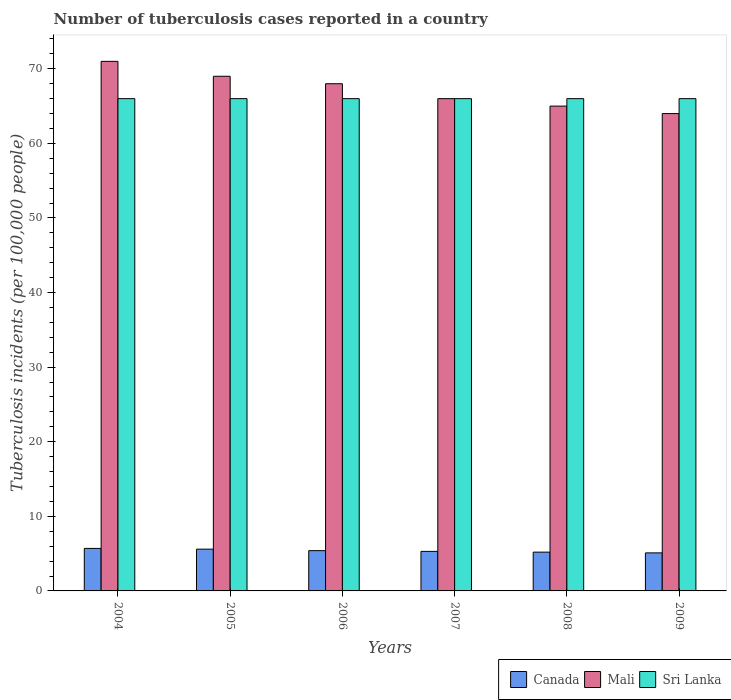How many groups of bars are there?
Make the answer very short. 6. How many bars are there on the 3rd tick from the right?
Offer a terse response. 3. What is the label of the 2nd group of bars from the left?
Offer a terse response. 2005. Across all years, what is the maximum number of tuberculosis cases reported in in Mali?
Ensure brevity in your answer.  71. What is the total number of tuberculosis cases reported in in Mali in the graph?
Your answer should be very brief. 403. What is the difference between the number of tuberculosis cases reported in in Canada in 2006 and that in 2008?
Offer a very short reply. 0.2. What is the difference between the number of tuberculosis cases reported in in Sri Lanka in 2006 and the number of tuberculosis cases reported in in Canada in 2004?
Give a very brief answer. 60.3. What is the average number of tuberculosis cases reported in in Canada per year?
Your response must be concise. 5.38. In the year 2004, what is the difference between the number of tuberculosis cases reported in in Sri Lanka and number of tuberculosis cases reported in in Mali?
Offer a terse response. -5. What is the ratio of the number of tuberculosis cases reported in in Canada in 2006 to that in 2009?
Provide a short and direct response. 1.06. Is the difference between the number of tuberculosis cases reported in in Sri Lanka in 2005 and 2006 greater than the difference between the number of tuberculosis cases reported in in Mali in 2005 and 2006?
Your answer should be compact. No. What is the difference between the highest and the lowest number of tuberculosis cases reported in in Canada?
Your answer should be compact. 0.6. In how many years, is the number of tuberculosis cases reported in in Sri Lanka greater than the average number of tuberculosis cases reported in in Sri Lanka taken over all years?
Your response must be concise. 0. Is the sum of the number of tuberculosis cases reported in in Canada in 2005 and 2009 greater than the maximum number of tuberculosis cases reported in in Sri Lanka across all years?
Your answer should be compact. No. What does the 3rd bar from the left in 2009 represents?
Offer a terse response. Sri Lanka. What does the 2nd bar from the right in 2006 represents?
Offer a terse response. Mali. How many bars are there?
Offer a terse response. 18. Are all the bars in the graph horizontal?
Give a very brief answer. No. What is the difference between two consecutive major ticks on the Y-axis?
Provide a short and direct response. 10. Does the graph contain any zero values?
Your answer should be compact. No. Does the graph contain grids?
Ensure brevity in your answer.  No. How many legend labels are there?
Ensure brevity in your answer.  3. How are the legend labels stacked?
Give a very brief answer. Horizontal. What is the title of the graph?
Offer a very short reply. Number of tuberculosis cases reported in a country. What is the label or title of the X-axis?
Provide a short and direct response. Years. What is the label or title of the Y-axis?
Offer a very short reply. Tuberculosis incidents (per 100,0 people). What is the Tuberculosis incidents (per 100,000 people) in Sri Lanka in 2004?
Make the answer very short. 66. What is the Tuberculosis incidents (per 100,000 people) in Canada in 2006?
Provide a succinct answer. 5.4. What is the Tuberculosis incidents (per 100,000 people) in Mali in 2006?
Keep it short and to the point. 68. What is the Tuberculosis incidents (per 100,000 people) of Sri Lanka in 2006?
Make the answer very short. 66. What is the Tuberculosis incidents (per 100,000 people) in Canada in 2007?
Your answer should be compact. 5.3. What is the Tuberculosis incidents (per 100,000 people) of Mali in 2007?
Your answer should be compact. 66. What is the Tuberculosis incidents (per 100,000 people) in Canada in 2008?
Offer a terse response. 5.2. What is the Tuberculosis incidents (per 100,000 people) in Canada in 2009?
Make the answer very short. 5.1. What is the Tuberculosis incidents (per 100,000 people) of Sri Lanka in 2009?
Offer a terse response. 66. Across all years, what is the minimum Tuberculosis incidents (per 100,000 people) in Sri Lanka?
Give a very brief answer. 66. What is the total Tuberculosis incidents (per 100,000 people) in Canada in the graph?
Make the answer very short. 32.3. What is the total Tuberculosis incidents (per 100,000 people) in Mali in the graph?
Provide a short and direct response. 403. What is the total Tuberculosis incidents (per 100,000 people) of Sri Lanka in the graph?
Give a very brief answer. 396. What is the difference between the Tuberculosis incidents (per 100,000 people) of Canada in 2004 and that in 2005?
Offer a terse response. 0.1. What is the difference between the Tuberculosis incidents (per 100,000 people) of Sri Lanka in 2004 and that in 2006?
Offer a very short reply. 0. What is the difference between the Tuberculosis incidents (per 100,000 people) in Mali in 2004 and that in 2007?
Offer a very short reply. 5. What is the difference between the Tuberculosis incidents (per 100,000 people) in Mali in 2004 and that in 2008?
Provide a succinct answer. 6. What is the difference between the Tuberculosis incidents (per 100,000 people) in Canada in 2004 and that in 2009?
Provide a succinct answer. 0.6. What is the difference between the Tuberculosis incidents (per 100,000 people) of Canada in 2005 and that in 2006?
Offer a very short reply. 0.2. What is the difference between the Tuberculosis incidents (per 100,000 people) in Canada in 2005 and that in 2007?
Provide a succinct answer. 0.3. What is the difference between the Tuberculosis incidents (per 100,000 people) in Mali in 2005 and that in 2007?
Provide a succinct answer. 3. What is the difference between the Tuberculosis incidents (per 100,000 people) of Sri Lanka in 2005 and that in 2009?
Ensure brevity in your answer.  0. What is the difference between the Tuberculosis incidents (per 100,000 people) of Sri Lanka in 2006 and that in 2007?
Make the answer very short. 0. What is the difference between the Tuberculosis incidents (per 100,000 people) in Canada in 2006 and that in 2008?
Your answer should be compact. 0.2. What is the difference between the Tuberculosis incidents (per 100,000 people) in Sri Lanka in 2006 and that in 2008?
Keep it short and to the point. 0. What is the difference between the Tuberculosis incidents (per 100,000 people) in Canada in 2006 and that in 2009?
Provide a short and direct response. 0.3. What is the difference between the Tuberculosis incidents (per 100,000 people) of Canada in 2007 and that in 2008?
Ensure brevity in your answer.  0.1. What is the difference between the Tuberculosis incidents (per 100,000 people) of Mali in 2008 and that in 2009?
Provide a short and direct response. 1. What is the difference between the Tuberculosis incidents (per 100,000 people) in Sri Lanka in 2008 and that in 2009?
Keep it short and to the point. 0. What is the difference between the Tuberculosis incidents (per 100,000 people) in Canada in 2004 and the Tuberculosis incidents (per 100,000 people) in Mali in 2005?
Your response must be concise. -63.3. What is the difference between the Tuberculosis incidents (per 100,000 people) in Canada in 2004 and the Tuberculosis incidents (per 100,000 people) in Sri Lanka in 2005?
Your answer should be compact. -60.3. What is the difference between the Tuberculosis incidents (per 100,000 people) of Canada in 2004 and the Tuberculosis incidents (per 100,000 people) of Mali in 2006?
Your answer should be compact. -62.3. What is the difference between the Tuberculosis incidents (per 100,000 people) in Canada in 2004 and the Tuberculosis incidents (per 100,000 people) in Sri Lanka in 2006?
Offer a terse response. -60.3. What is the difference between the Tuberculosis incidents (per 100,000 people) in Mali in 2004 and the Tuberculosis incidents (per 100,000 people) in Sri Lanka in 2006?
Offer a terse response. 5. What is the difference between the Tuberculosis incidents (per 100,000 people) in Canada in 2004 and the Tuberculosis incidents (per 100,000 people) in Mali in 2007?
Make the answer very short. -60.3. What is the difference between the Tuberculosis incidents (per 100,000 people) in Canada in 2004 and the Tuberculosis incidents (per 100,000 people) in Sri Lanka in 2007?
Keep it short and to the point. -60.3. What is the difference between the Tuberculosis incidents (per 100,000 people) of Mali in 2004 and the Tuberculosis incidents (per 100,000 people) of Sri Lanka in 2007?
Offer a terse response. 5. What is the difference between the Tuberculosis incidents (per 100,000 people) in Canada in 2004 and the Tuberculosis incidents (per 100,000 people) in Mali in 2008?
Your answer should be very brief. -59.3. What is the difference between the Tuberculosis incidents (per 100,000 people) in Canada in 2004 and the Tuberculosis incidents (per 100,000 people) in Sri Lanka in 2008?
Your answer should be compact. -60.3. What is the difference between the Tuberculosis incidents (per 100,000 people) in Mali in 2004 and the Tuberculosis incidents (per 100,000 people) in Sri Lanka in 2008?
Provide a short and direct response. 5. What is the difference between the Tuberculosis incidents (per 100,000 people) of Canada in 2004 and the Tuberculosis incidents (per 100,000 people) of Mali in 2009?
Your answer should be compact. -58.3. What is the difference between the Tuberculosis incidents (per 100,000 people) in Canada in 2004 and the Tuberculosis incidents (per 100,000 people) in Sri Lanka in 2009?
Offer a very short reply. -60.3. What is the difference between the Tuberculosis incidents (per 100,000 people) of Mali in 2004 and the Tuberculosis incidents (per 100,000 people) of Sri Lanka in 2009?
Ensure brevity in your answer.  5. What is the difference between the Tuberculosis incidents (per 100,000 people) in Canada in 2005 and the Tuberculosis incidents (per 100,000 people) in Mali in 2006?
Offer a very short reply. -62.4. What is the difference between the Tuberculosis incidents (per 100,000 people) of Canada in 2005 and the Tuberculosis incidents (per 100,000 people) of Sri Lanka in 2006?
Offer a very short reply. -60.4. What is the difference between the Tuberculosis incidents (per 100,000 people) of Mali in 2005 and the Tuberculosis incidents (per 100,000 people) of Sri Lanka in 2006?
Keep it short and to the point. 3. What is the difference between the Tuberculosis incidents (per 100,000 people) in Canada in 2005 and the Tuberculosis incidents (per 100,000 people) in Mali in 2007?
Your response must be concise. -60.4. What is the difference between the Tuberculosis incidents (per 100,000 people) in Canada in 2005 and the Tuberculosis incidents (per 100,000 people) in Sri Lanka in 2007?
Offer a terse response. -60.4. What is the difference between the Tuberculosis incidents (per 100,000 people) of Mali in 2005 and the Tuberculosis incidents (per 100,000 people) of Sri Lanka in 2007?
Your answer should be compact. 3. What is the difference between the Tuberculosis incidents (per 100,000 people) of Canada in 2005 and the Tuberculosis incidents (per 100,000 people) of Mali in 2008?
Provide a succinct answer. -59.4. What is the difference between the Tuberculosis incidents (per 100,000 people) of Canada in 2005 and the Tuberculosis incidents (per 100,000 people) of Sri Lanka in 2008?
Offer a terse response. -60.4. What is the difference between the Tuberculosis incidents (per 100,000 people) in Canada in 2005 and the Tuberculosis incidents (per 100,000 people) in Mali in 2009?
Your response must be concise. -58.4. What is the difference between the Tuberculosis incidents (per 100,000 people) in Canada in 2005 and the Tuberculosis incidents (per 100,000 people) in Sri Lanka in 2009?
Provide a succinct answer. -60.4. What is the difference between the Tuberculosis incidents (per 100,000 people) of Mali in 2005 and the Tuberculosis incidents (per 100,000 people) of Sri Lanka in 2009?
Provide a short and direct response. 3. What is the difference between the Tuberculosis incidents (per 100,000 people) in Canada in 2006 and the Tuberculosis incidents (per 100,000 people) in Mali in 2007?
Your response must be concise. -60.6. What is the difference between the Tuberculosis incidents (per 100,000 people) of Canada in 2006 and the Tuberculosis incidents (per 100,000 people) of Sri Lanka in 2007?
Offer a very short reply. -60.6. What is the difference between the Tuberculosis incidents (per 100,000 people) of Canada in 2006 and the Tuberculosis incidents (per 100,000 people) of Mali in 2008?
Your response must be concise. -59.6. What is the difference between the Tuberculosis incidents (per 100,000 people) in Canada in 2006 and the Tuberculosis incidents (per 100,000 people) in Sri Lanka in 2008?
Provide a short and direct response. -60.6. What is the difference between the Tuberculosis incidents (per 100,000 people) of Mali in 2006 and the Tuberculosis incidents (per 100,000 people) of Sri Lanka in 2008?
Offer a terse response. 2. What is the difference between the Tuberculosis incidents (per 100,000 people) in Canada in 2006 and the Tuberculosis incidents (per 100,000 people) in Mali in 2009?
Provide a short and direct response. -58.6. What is the difference between the Tuberculosis incidents (per 100,000 people) of Canada in 2006 and the Tuberculosis incidents (per 100,000 people) of Sri Lanka in 2009?
Make the answer very short. -60.6. What is the difference between the Tuberculosis incidents (per 100,000 people) in Canada in 2007 and the Tuberculosis incidents (per 100,000 people) in Mali in 2008?
Offer a very short reply. -59.7. What is the difference between the Tuberculosis incidents (per 100,000 people) in Canada in 2007 and the Tuberculosis incidents (per 100,000 people) in Sri Lanka in 2008?
Provide a short and direct response. -60.7. What is the difference between the Tuberculosis incidents (per 100,000 people) in Mali in 2007 and the Tuberculosis incidents (per 100,000 people) in Sri Lanka in 2008?
Provide a succinct answer. 0. What is the difference between the Tuberculosis incidents (per 100,000 people) in Canada in 2007 and the Tuberculosis incidents (per 100,000 people) in Mali in 2009?
Offer a terse response. -58.7. What is the difference between the Tuberculosis incidents (per 100,000 people) of Canada in 2007 and the Tuberculosis incidents (per 100,000 people) of Sri Lanka in 2009?
Make the answer very short. -60.7. What is the difference between the Tuberculosis incidents (per 100,000 people) in Canada in 2008 and the Tuberculosis incidents (per 100,000 people) in Mali in 2009?
Offer a very short reply. -58.8. What is the difference between the Tuberculosis incidents (per 100,000 people) of Canada in 2008 and the Tuberculosis incidents (per 100,000 people) of Sri Lanka in 2009?
Your answer should be very brief. -60.8. What is the difference between the Tuberculosis incidents (per 100,000 people) of Mali in 2008 and the Tuberculosis incidents (per 100,000 people) of Sri Lanka in 2009?
Your answer should be very brief. -1. What is the average Tuberculosis incidents (per 100,000 people) of Canada per year?
Provide a short and direct response. 5.38. What is the average Tuberculosis incidents (per 100,000 people) in Mali per year?
Provide a succinct answer. 67.17. In the year 2004, what is the difference between the Tuberculosis incidents (per 100,000 people) of Canada and Tuberculosis incidents (per 100,000 people) of Mali?
Ensure brevity in your answer.  -65.3. In the year 2004, what is the difference between the Tuberculosis incidents (per 100,000 people) in Canada and Tuberculosis incidents (per 100,000 people) in Sri Lanka?
Your answer should be compact. -60.3. In the year 2005, what is the difference between the Tuberculosis incidents (per 100,000 people) in Canada and Tuberculosis incidents (per 100,000 people) in Mali?
Your response must be concise. -63.4. In the year 2005, what is the difference between the Tuberculosis incidents (per 100,000 people) of Canada and Tuberculosis incidents (per 100,000 people) of Sri Lanka?
Keep it short and to the point. -60.4. In the year 2005, what is the difference between the Tuberculosis incidents (per 100,000 people) of Mali and Tuberculosis incidents (per 100,000 people) of Sri Lanka?
Provide a short and direct response. 3. In the year 2006, what is the difference between the Tuberculosis incidents (per 100,000 people) in Canada and Tuberculosis incidents (per 100,000 people) in Mali?
Offer a very short reply. -62.6. In the year 2006, what is the difference between the Tuberculosis incidents (per 100,000 people) of Canada and Tuberculosis incidents (per 100,000 people) of Sri Lanka?
Provide a succinct answer. -60.6. In the year 2007, what is the difference between the Tuberculosis incidents (per 100,000 people) in Canada and Tuberculosis incidents (per 100,000 people) in Mali?
Your answer should be compact. -60.7. In the year 2007, what is the difference between the Tuberculosis incidents (per 100,000 people) of Canada and Tuberculosis incidents (per 100,000 people) of Sri Lanka?
Your answer should be compact. -60.7. In the year 2007, what is the difference between the Tuberculosis incidents (per 100,000 people) of Mali and Tuberculosis incidents (per 100,000 people) of Sri Lanka?
Make the answer very short. 0. In the year 2008, what is the difference between the Tuberculosis incidents (per 100,000 people) in Canada and Tuberculosis incidents (per 100,000 people) in Mali?
Offer a terse response. -59.8. In the year 2008, what is the difference between the Tuberculosis incidents (per 100,000 people) of Canada and Tuberculosis incidents (per 100,000 people) of Sri Lanka?
Provide a succinct answer. -60.8. In the year 2008, what is the difference between the Tuberculosis incidents (per 100,000 people) in Mali and Tuberculosis incidents (per 100,000 people) in Sri Lanka?
Give a very brief answer. -1. In the year 2009, what is the difference between the Tuberculosis incidents (per 100,000 people) of Canada and Tuberculosis incidents (per 100,000 people) of Mali?
Offer a terse response. -58.9. In the year 2009, what is the difference between the Tuberculosis incidents (per 100,000 people) of Canada and Tuberculosis incidents (per 100,000 people) of Sri Lanka?
Your response must be concise. -60.9. What is the ratio of the Tuberculosis incidents (per 100,000 people) in Canada in 2004 to that in 2005?
Provide a short and direct response. 1.02. What is the ratio of the Tuberculosis incidents (per 100,000 people) in Sri Lanka in 2004 to that in 2005?
Make the answer very short. 1. What is the ratio of the Tuberculosis incidents (per 100,000 people) in Canada in 2004 to that in 2006?
Your answer should be very brief. 1.06. What is the ratio of the Tuberculosis incidents (per 100,000 people) of Mali in 2004 to that in 2006?
Your answer should be very brief. 1.04. What is the ratio of the Tuberculosis incidents (per 100,000 people) in Canada in 2004 to that in 2007?
Give a very brief answer. 1.08. What is the ratio of the Tuberculosis incidents (per 100,000 people) in Mali in 2004 to that in 2007?
Make the answer very short. 1.08. What is the ratio of the Tuberculosis incidents (per 100,000 people) of Canada in 2004 to that in 2008?
Your response must be concise. 1.1. What is the ratio of the Tuberculosis incidents (per 100,000 people) of Mali in 2004 to that in 2008?
Give a very brief answer. 1.09. What is the ratio of the Tuberculosis incidents (per 100,000 people) of Canada in 2004 to that in 2009?
Offer a very short reply. 1.12. What is the ratio of the Tuberculosis incidents (per 100,000 people) of Mali in 2004 to that in 2009?
Offer a very short reply. 1.11. What is the ratio of the Tuberculosis incidents (per 100,000 people) in Sri Lanka in 2004 to that in 2009?
Offer a terse response. 1. What is the ratio of the Tuberculosis incidents (per 100,000 people) in Canada in 2005 to that in 2006?
Offer a very short reply. 1.04. What is the ratio of the Tuberculosis incidents (per 100,000 people) of Mali in 2005 to that in 2006?
Provide a short and direct response. 1.01. What is the ratio of the Tuberculosis incidents (per 100,000 people) in Sri Lanka in 2005 to that in 2006?
Offer a terse response. 1. What is the ratio of the Tuberculosis incidents (per 100,000 people) of Canada in 2005 to that in 2007?
Your answer should be compact. 1.06. What is the ratio of the Tuberculosis incidents (per 100,000 people) in Mali in 2005 to that in 2007?
Provide a short and direct response. 1.05. What is the ratio of the Tuberculosis incidents (per 100,000 people) in Canada in 2005 to that in 2008?
Ensure brevity in your answer.  1.08. What is the ratio of the Tuberculosis incidents (per 100,000 people) in Mali in 2005 to that in 2008?
Provide a short and direct response. 1.06. What is the ratio of the Tuberculosis incidents (per 100,000 people) of Canada in 2005 to that in 2009?
Ensure brevity in your answer.  1.1. What is the ratio of the Tuberculosis incidents (per 100,000 people) of Mali in 2005 to that in 2009?
Ensure brevity in your answer.  1.08. What is the ratio of the Tuberculosis incidents (per 100,000 people) in Sri Lanka in 2005 to that in 2009?
Offer a very short reply. 1. What is the ratio of the Tuberculosis incidents (per 100,000 people) in Canada in 2006 to that in 2007?
Keep it short and to the point. 1.02. What is the ratio of the Tuberculosis incidents (per 100,000 people) in Mali in 2006 to that in 2007?
Your response must be concise. 1.03. What is the ratio of the Tuberculosis incidents (per 100,000 people) in Sri Lanka in 2006 to that in 2007?
Ensure brevity in your answer.  1. What is the ratio of the Tuberculosis incidents (per 100,000 people) in Canada in 2006 to that in 2008?
Provide a short and direct response. 1.04. What is the ratio of the Tuberculosis incidents (per 100,000 people) in Mali in 2006 to that in 2008?
Give a very brief answer. 1.05. What is the ratio of the Tuberculosis incidents (per 100,000 people) in Sri Lanka in 2006 to that in 2008?
Keep it short and to the point. 1. What is the ratio of the Tuberculosis incidents (per 100,000 people) in Canada in 2006 to that in 2009?
Give a very brief answer. 1.06. What is the ratio of the Tuberculosis incidents (per 100,000 people) of Mali in 2006 to that in 2009?
Provide a succinct answer. 1.06. What is the ratio of the Tuberculosis incidents (per 100,000 people) of Sri Lanka in 2006 to that in 2009?
Offer a very short reply. 1. What is the ratio of the Tuberculosis incidents (per 100,000 people) in Canada in 2007 to that in 2008?
Offer a very short reply. 1.02. What is the ratio of the Tuberculosis incidents (per 100,000 people) in Mali in 2007 to that in 2008?
Ensure brevity in your answer.  1.02. What is the ratio of the Tuberculosis incidents (per 100,000 people) in Canada in 2007 to that in 2009?
Keep it short and to the point. 1.04. What is the ratio of the Tuberculosis incidents (per 100,000 people) of Mali in 2007 to that in 2009?
Your response must be concise. 1.03. What is the ratio of the Tuberculosis incidents (per 100,000 people) of Canada in 2008 to that in 2009?
Provide a short and direct response. 1.02. What is the ratio of the Tuberculosis incidents (per 100,000 people) of Mali in 2008 to that in 2009?
Your answer should be very brief. 1.02. What is the difference between the highest and the second highest Tuberculosis incidents (per 100,000 people) of Canada?
Offer a terse response. 0.1. 